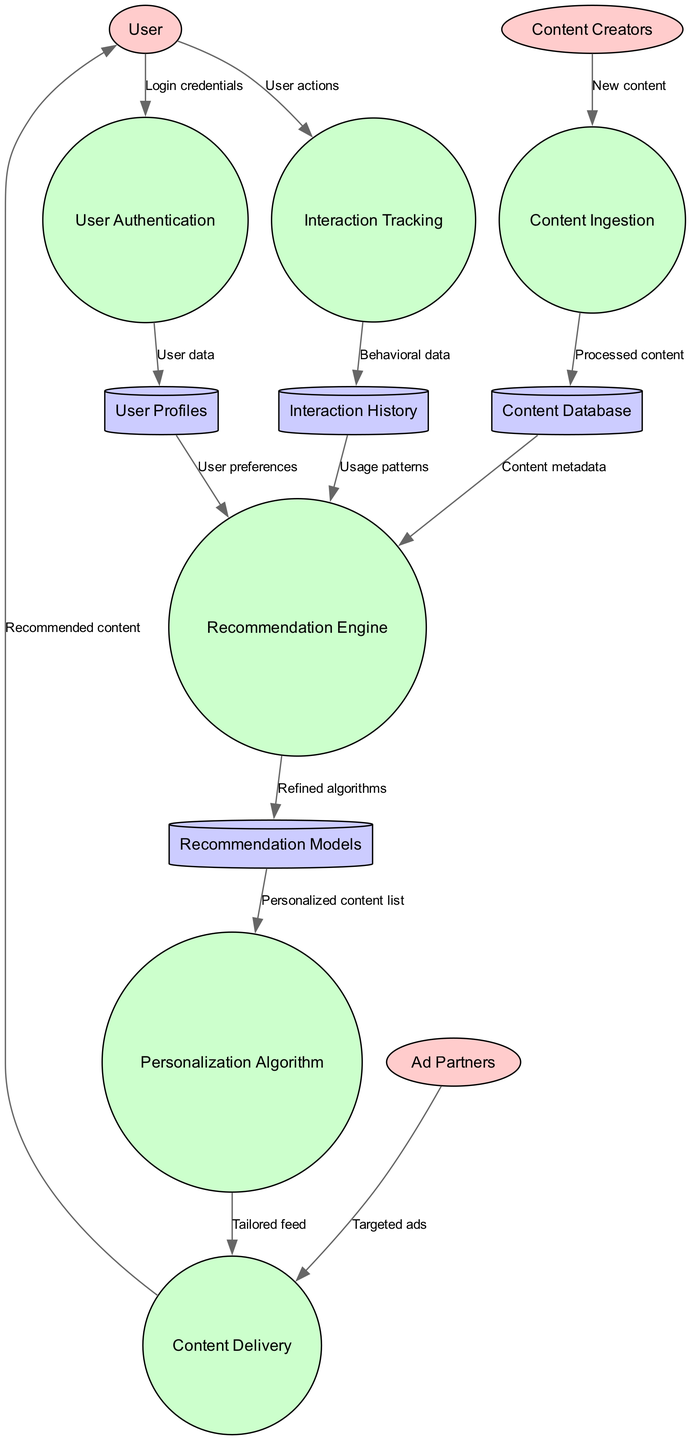What are the external entities represented in the diagram? The external entities shown in the diagram include "User," "Content Creators," and "Ad Partners." These are connected to various processes indicating their interactions.
Answer: User, Content Creators, Ad Partners How many processes are depicted in the diagram? The diagram contains six distinct processes: "User Authentication," "Content Ingestion," "Interaction Tracking," "Recommendation Engine," "Personalization Algorithm," and "Content Delivery." Therefore, the total is six.
Answer: 6 What is the output of the "Recommendation Engine"? The "Recommendation Engine" outputs "Recommendation Models," which are refined algorithms used for personalized content understanding. This follows from the input it receives from user profiles, interaction history, and content metadata.
Answer: Recommendation Models Which process receives interaction data from users? The process that receives interaction data from users is "Interaction Tracking," which records user actions to understand their behavior better.
Answer: Interaction Tracking What data flows into the "Personalization Algorithm"? The data flowing into the "Personalization Algorithm" consists of "Personalized content list," which is the output from the "Recommendation Models." This link shows how refined algorithms are utilized to create a tailored experience for the user.
Answer: Personalized content list How many data stores are there in the diagram? There are four data stores indicated in the diagram: "User Profiles," "Content Database," "Interaction History," and "Recommendation Models." Therefore, the total is four.
Answer: 4 What is the relationship between "Content Ingestion" and "Content Database"? The relationship between "Content Ingestion" and "Content Database" is that "Content Ingestion" processes new content and sends it to the "Content Database," where it is stored and managed.
Answer: Processes new content Which entity sends targeted ads to "Content Delivery"? The entity that sends targeted ads to "Content Delivery" is "Ad Partners." This relationship indicates the monetization aspect of the content platform.
Answer: Ad Partners What is the purpose of "User Authentication"? The purpose of "User Authentication" is to validate the "Login credentials" provided by the "User," ensuring that only authorized users can access their accounts.
Answer: Validate login credentials 